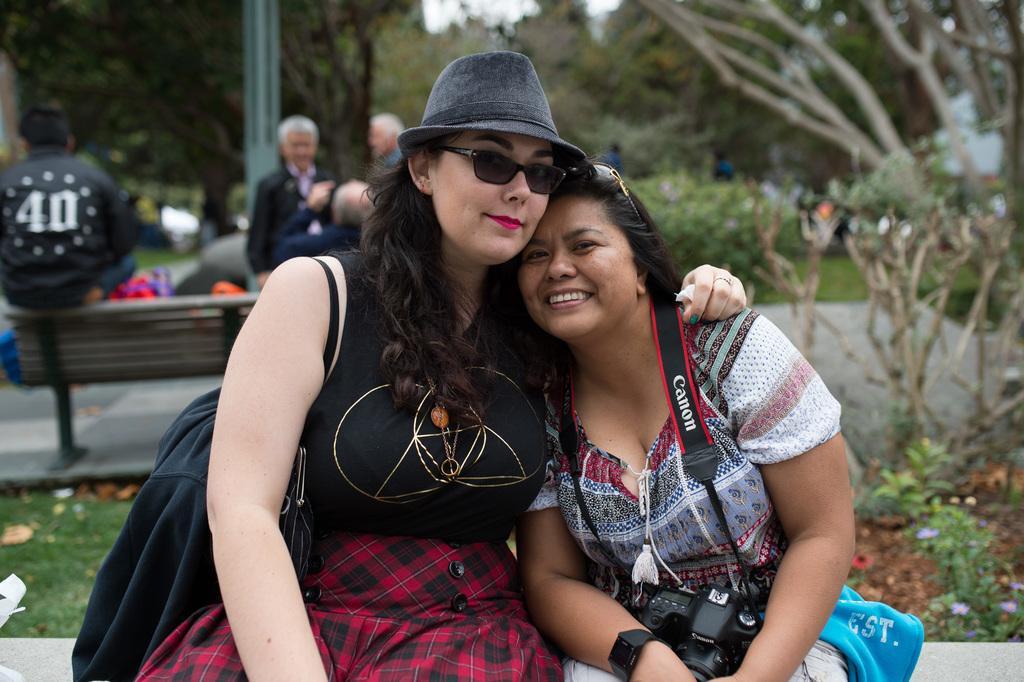In one or two sentences, can you explain what this image depicts? In this image I can see some people. In the background, I can see a bench and the trees. 